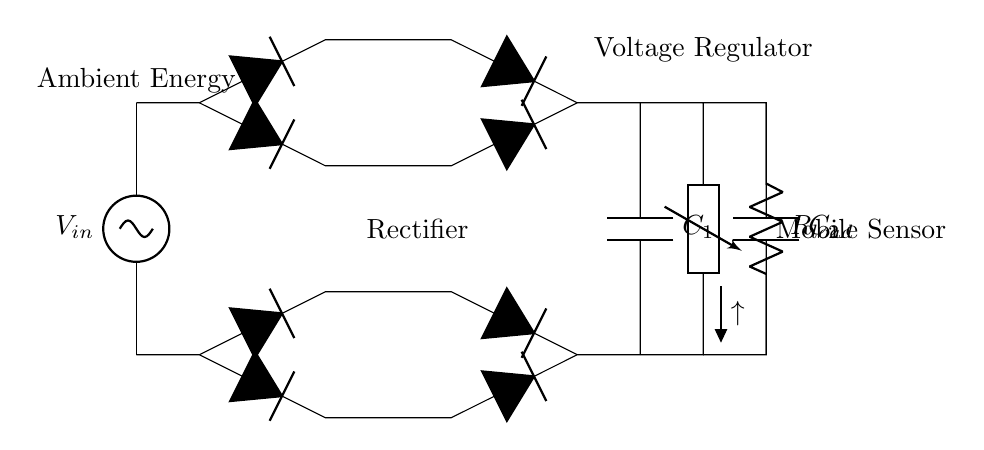What is the input voltage source in this circuit? The circuit diagram indicates that the input voltage is labeled as V_in, which is the ambient energy source feeding into the circuit.
Answer: V_in What is the function of the component labeled C1? The capacitor C1 is connected to the output of the rectifier bridge and is used for smoothing the rectified voltage, which helps to reduce voltage ripple.
Answer: Smoothing What type of rectifier is used in this circuit? The circuit uses a bridge rectifier formed by four diodes which convert the AC input voltage into a DC output voltage.
Answer: Bridge What is the role of the DC-DC converter in this circuit? The DC-DC converter adjusts the voltage level, increasing or decreasing it as necessary to supply a steady output voltage suitable for the load (mobile sensor).
Answer: Voltage regulation How many diodes are present in the rectifier section of the circuit? The rectifier section features four diodes arranged in a bridge configuration to ensure efficient rectification of the AC input.
Answer: Four What does the load resistance R_load represent in the context of this circuit? R_load represents the mobile sensor that consumes power, and its presence in the circuit indicates where the harvested energy will be utilized.
Answer: Mobile sensor 